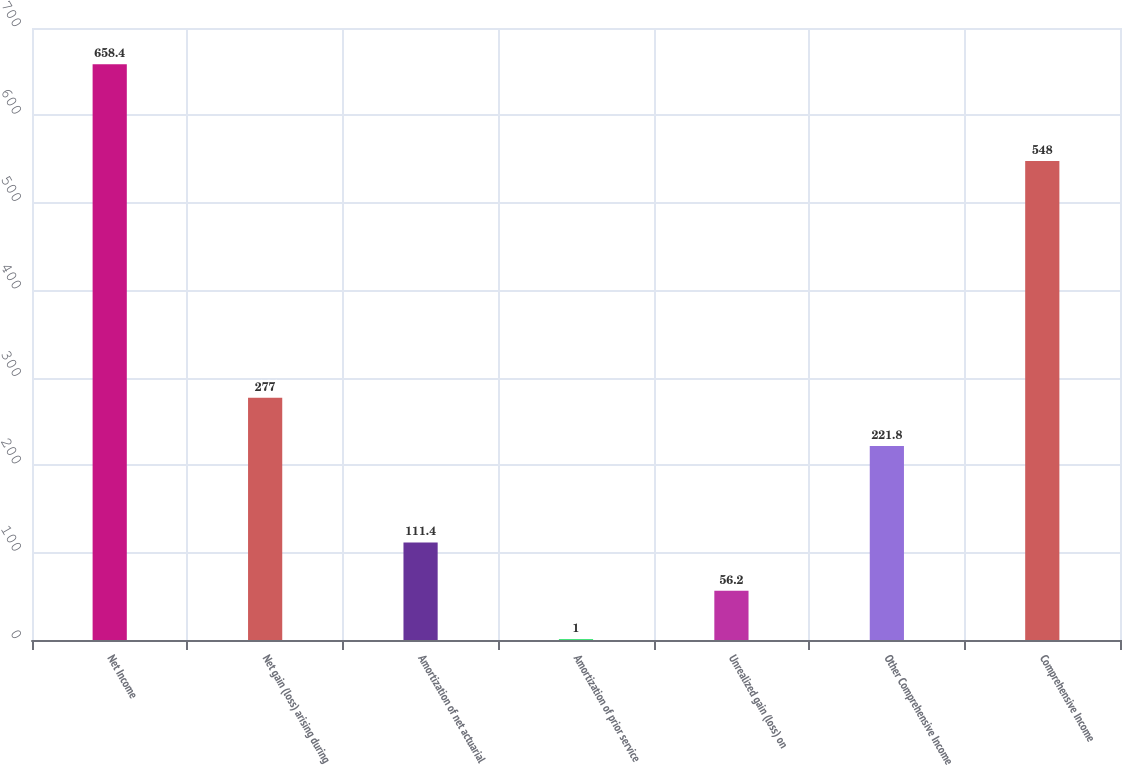Convert chart. <chart><loc_0><loc_0><loc_500><loc_500><bar_chart><fcel>Net Income<fcel>Net gain (loss) arising during<fcel>Amortization of net actuarial<fcel>Amortization of prior service<fcel>Unrealized gain (loss) on<fcel>Other Comprehensive Income<fcel>Comprehensive Income<nl><fcel>658.4<fcel>277<fcel>111.4<fcel>1<fcel>56.2<fcel>221.8<fcel>548<nl></chart> 